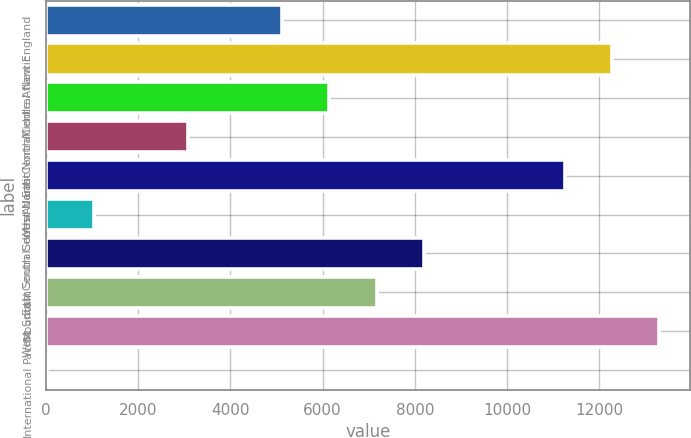Convert chart to OTSL. <chart><loc_0><loc_0><loc_500><loc_500><bar_chart><fcel>New England<fcel>Middle Atlantic<fcel>East North Central<fcel>West North Central<fcel>South Atlantic<fcel>East South Central<fcel>West South Central<fcel>Mountain<fcel>Pacific<fcel>International<nl><fcel>5125.35<fcel>12279<fcel>6147.3<fcel>3081.45<fcel>11257<fcel>1037.55<fcel>8191.2<fcel>7169.25<fcel>13301<fcel>15.6<nl></chart> 